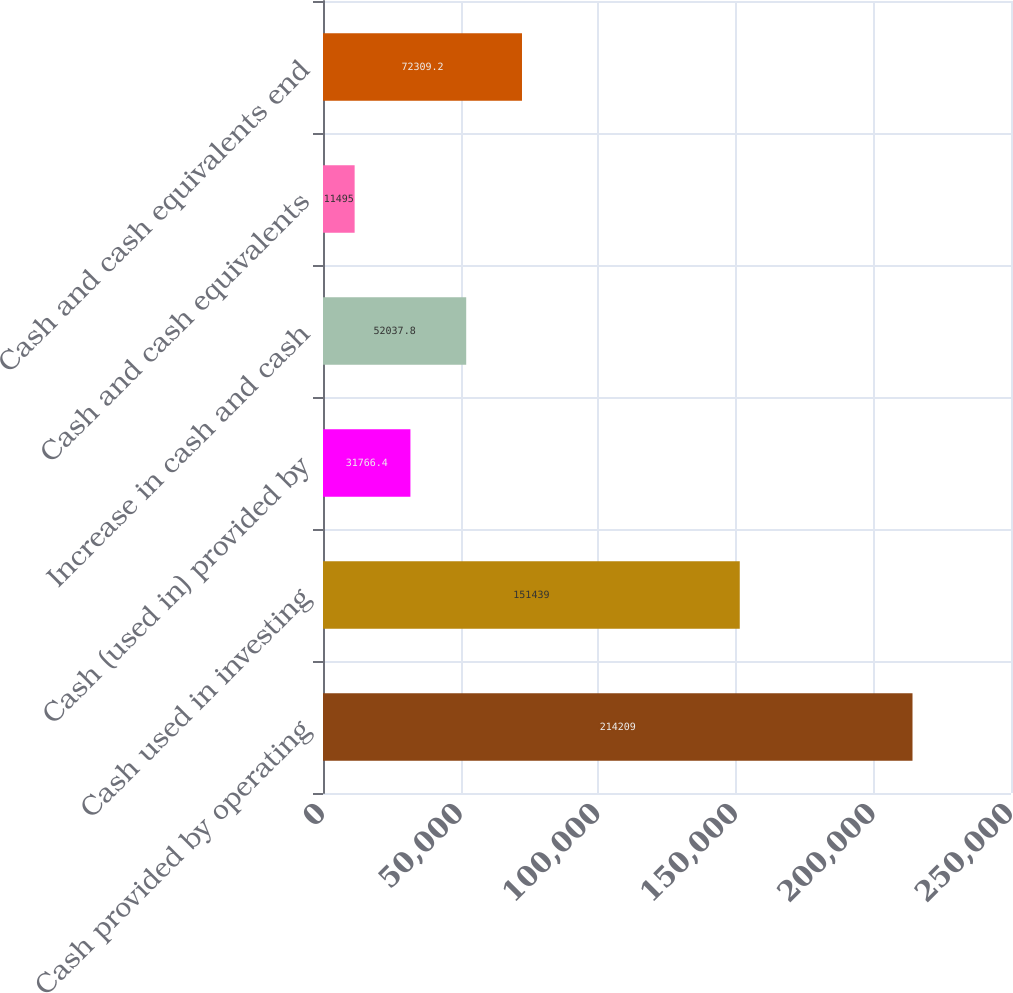Convert chart. <chart><loc_0><loc_0><loc_500><loc_500><bar_chart><fcel>Cash provided by operating<fcel>Cash used in investing<fcel>Cash (used in) provided by<fcel>Increase in cash and cash<fcel>Cash and cash equivalents<fcel>Cash and cash equivalents end<nl><fcel>214209<fcel>151439<fcel>31766.4<fcel>52037.8<fcel>11495<fcel>72309.2<nl></chart> 